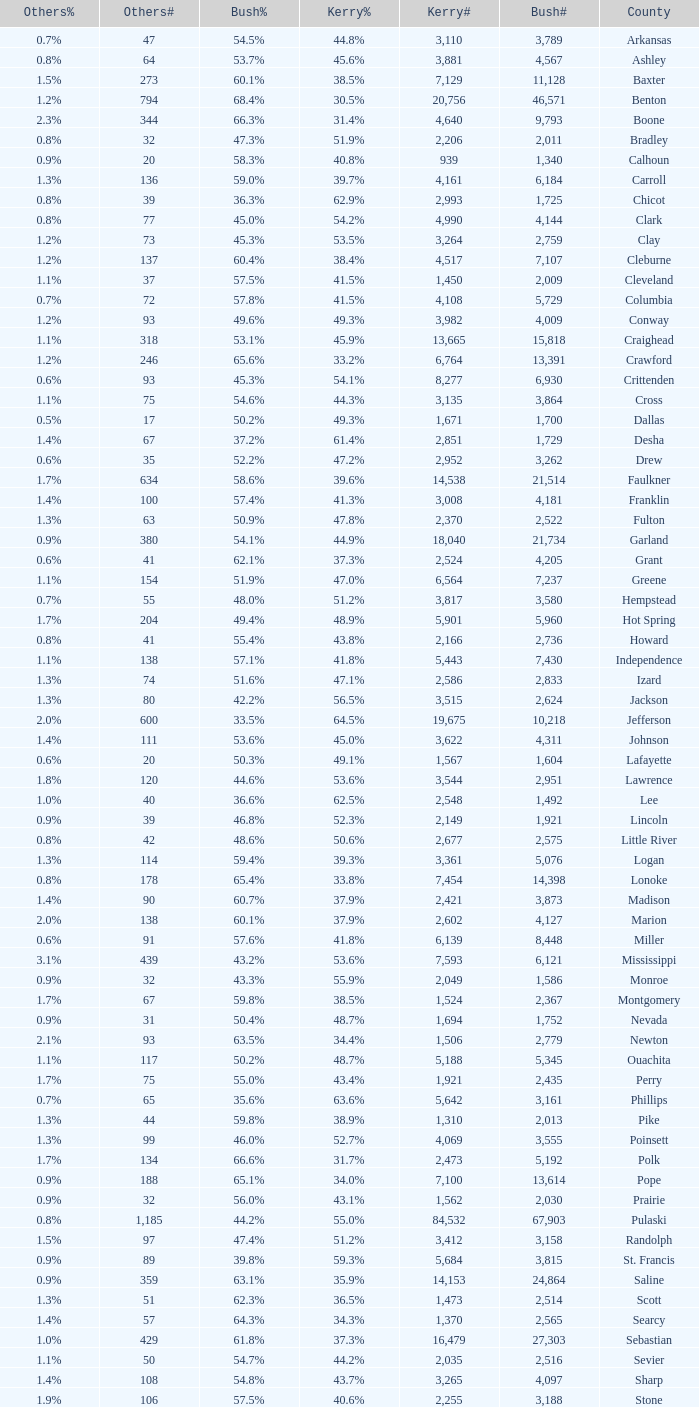What is the lowest Bush#, when Bush% is "65.4%"? 14398.0. 